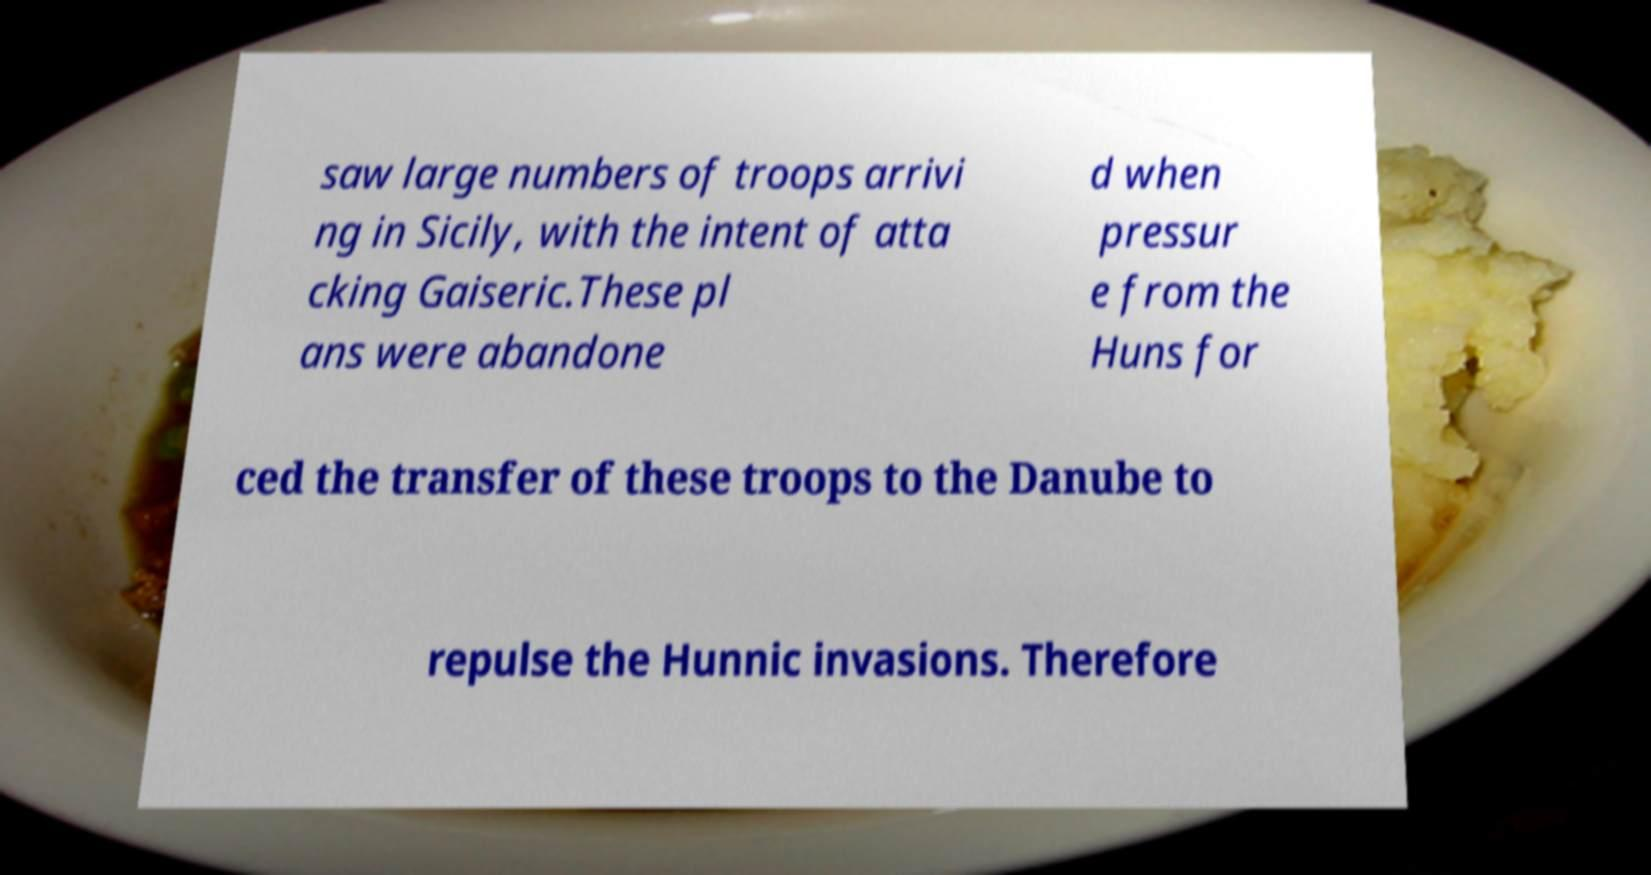What messages or text are displayed in this image? I need them in a readable, typed format. saw large numbers of troops arrivi ng in Sicily, with the intent of atta cking Gaiseric.These pl ans were abandone d when pressur e from the Huns for ced the transfer of these troops to the Danube to repulse the Hunnic invasions. Therefore 